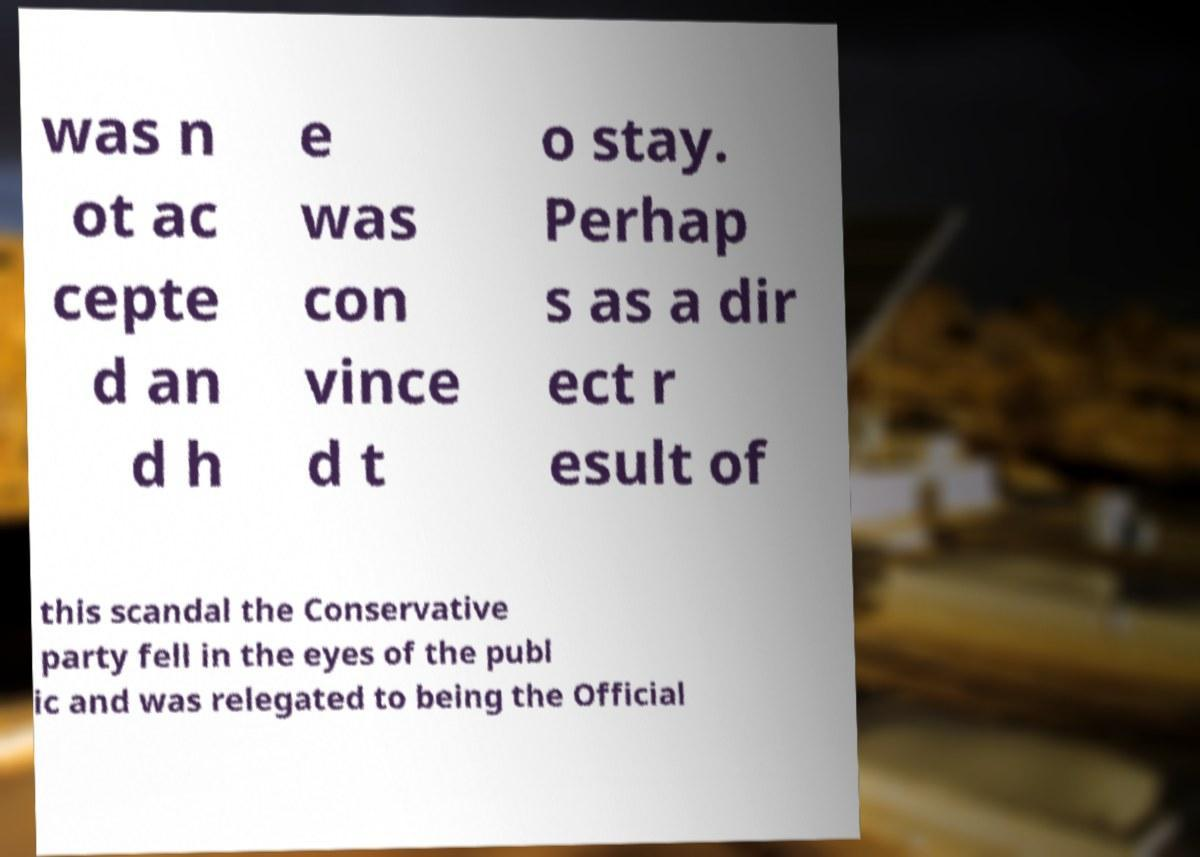Please read and relay the text visible in this image. What does it say? was n ot ac cepte d an d h e was con vince d t o stay. Perhap s as a dir ect r esult of this scandal the Conservative party fell in the eyes of the publ ic and was relegated to being the Official 